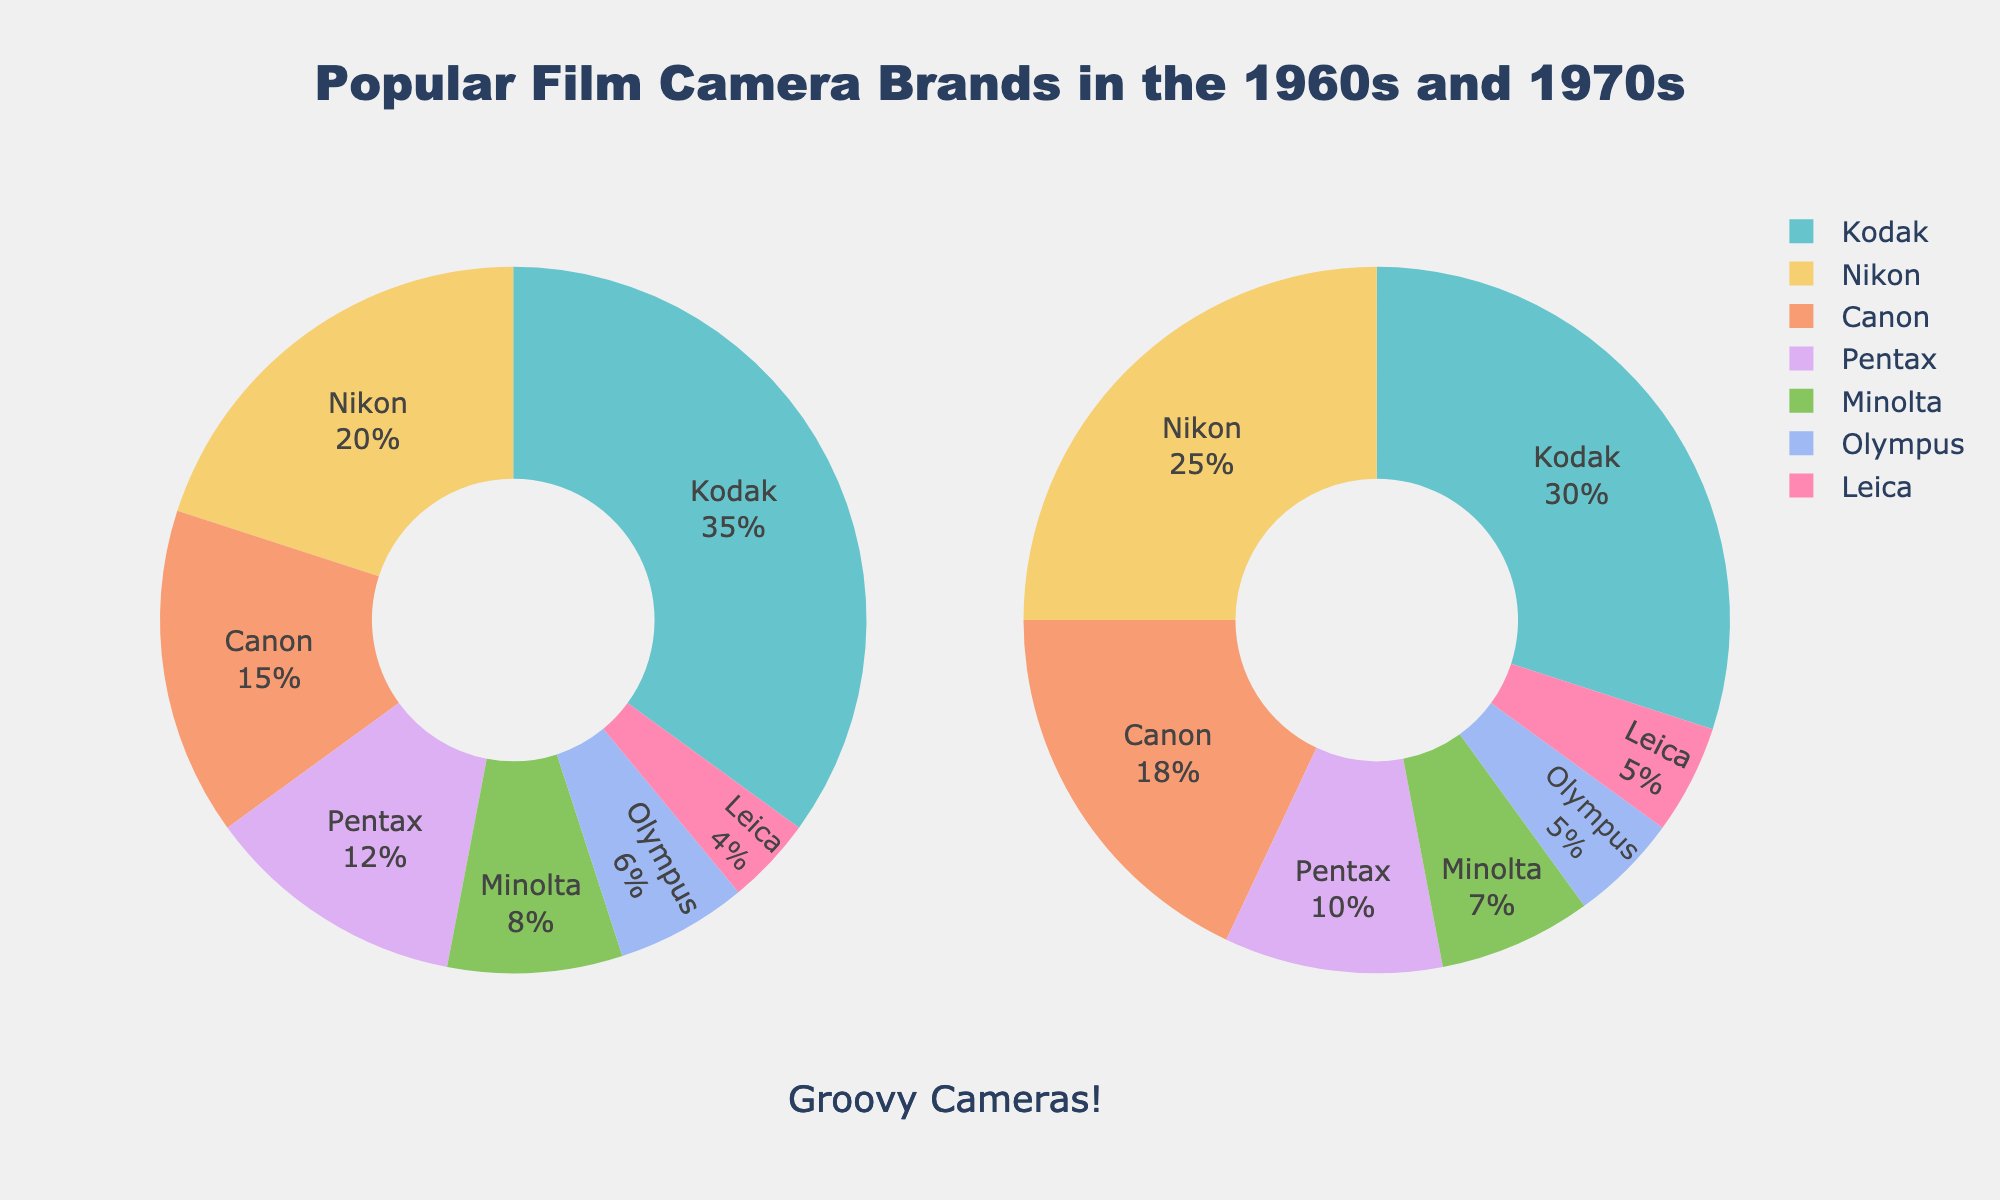Which brand had the largest market share in the 1960s? The brand with the largest section in the left pie chart represents the largest market share. Kodak has the largest section in the 1960s pie chart.
Answer: Kodak Compare the market share change of Nikon from the 1960s to the 1970s. In the 1960s, Nikon had a 20% market share, and in the 1970s, it had a 25% market share. The market share increased by 5%.
Answer: Increased by 5% What is the total market share of Kodak and Canon in the 1970s? Canon has an 18% market share, and Kodak has a 30% market share in the 1970s. Summing these two shares gives 30% + 18% = 48%.
Answer: 48% Which brand had a lower market share in the 1970s compared to the 1960s? Brands with reduced sections in the 1970s pie chart compared to the 1960s include Kodak, Pentax, Minolta, and Olympus. Each had a smaller market share in the 1970s than in the 1960s.
Answer: Kodak, Pentax, Minolta, Olympus What is the combined market share of all brands with less than 10% market share in the 1970s? Less than 10% in the 1970s includes Pentax (10%), Minolta (7%), and Olympus (5%). Summing these values gives 10% + 7% + 5% = 22%.
Answer: 22% Which brands increased their market share from the 1960s to the 1970s? Brands with a larger section in the 1970s pie chart than in the 1960s pie chart are Nikon, Canon, and Leica. Each had an increased market share in the 1970s compared to the 1960s.
Answer: Nikon, Canon, Leica How did the market share of Olympus change from the 1960s to the 1970s? Olympus had a 6% market share in the 1960s and a 5% market share in the 1970s. The market share decreased by 1%.
Answer: Decreased by 1% What is the difference in the market share of Pentax between the 1960s and 1970s? Pentax had a 12% market share in the 1960s and a 10% market share in the 1970s. The difference is 12% - 10% = 2%.
Answer: 2% What percentage of the market did Minolta capture in the 1960s and 1970s combined? Minolta had an 8% market share in the 1960s and a 7% market share in the 1970s. Summing these values, 8% + 7% = 15%.
Answer: 15% 